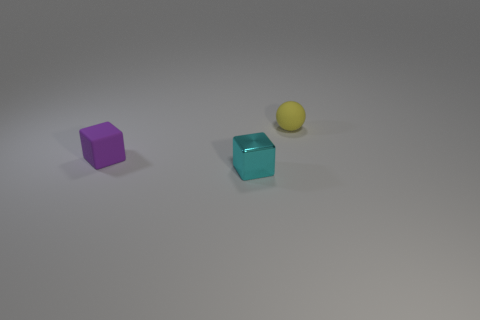Add 1 small cubes. How many objects exist? 4 Subtract all cubes. How many objects are left? 1 Add 1 large cubes. How many large cubes exist? 1 Subtract 0 blue balls. How many objects are left? 3 Subtract all red rubber cylinders. Subtract all yellow matte spheres. How many objects are left? 2 Add 2 tiny cyan metallic things. How many tiny cyan metallic things are left? 3 